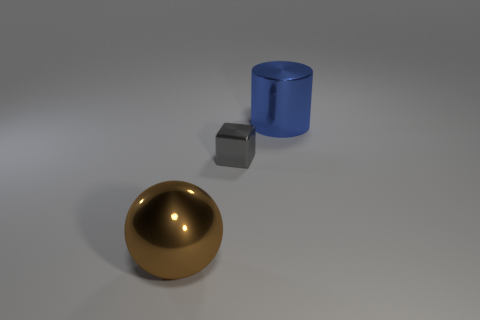What materials are the objects in the image made of? The objects in the image appear to be made of different materials; the sphere looks like it could be made of polished bronze, the cube appears to be made of a matte silver-like metal, and the cylinder seems to be made of a reflective blue metal or plastic. 